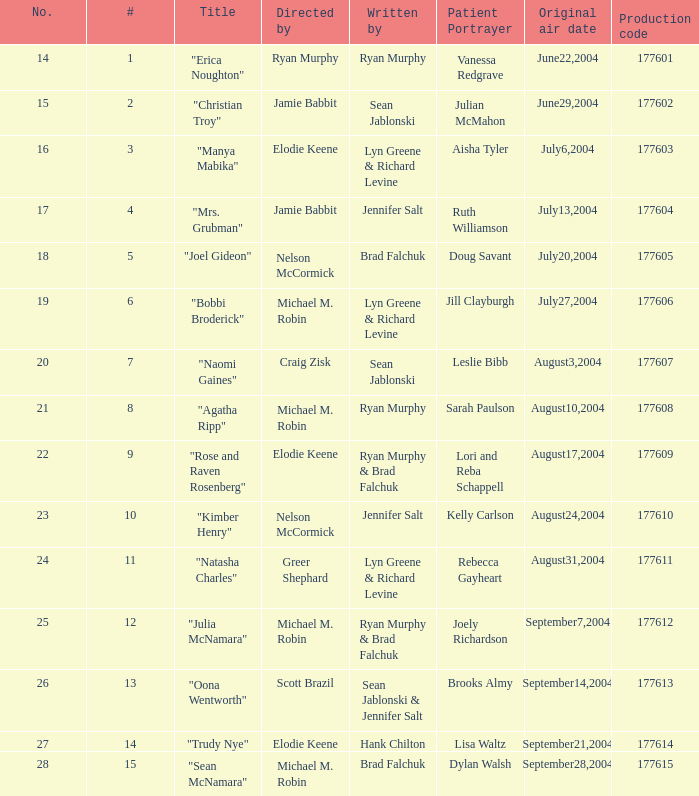Could you parse the entire table as a dict? {'header': ['No.', '#', 'Title', 'Directed by', 'Written by', 'Patient Portrayer', 'Original air date', 'Production code'], 'rows': [['14', '1', '"Erica Noughton"', 'Ryan Murphy', 'Ryan Murphy', 'Vanessa Redgrave', 'June22,2004', '177601'], ['15', '2', '"Christian Troy"', 'Jamie Babbit', 'Sean Jablonski', 'Julian McMahon', 'June29,2004', '177602'], ['16', '3', '"Manya Mabika"', 'Elodie Keene', 'Lyn Greene & Richard Levine', 'Aisha Tyler', 'July6,2004', '177603'], ['17', '4', '"Mrs. Grubman"', 'Jamie Babbit', 'Jennifer Salt', 'Ruth Williamson', 'July13,2004', '177604'], ['18', '5', '"Joel Gideon"', 'Nelson McCormick', 'Brad Falchuk', 'Doug Savant', 'July20,2004', '177605'], ['19', '6', '"Bobbi Broderick"', 'Michael M. Robin', 'Lyn Greene & Richard Levine', 'Jill Clayburgh', 'July27,2004', '177606'], ['20', '7', '"Naomi Gaines"', 'Craig Zisk', 'Sean Jablonski', 'Leslie Bibb', 'August3,2004', '177607'], ['21', '8', '"Agatha Ripp"', 'Michael M. Robin', 'Ryan Murphy', 'Sarah Paulson', 'August10,2004', '177608'], ['22', '9', '"Rose and Raven Rosenberg"', 'Elodie Keene', 'Ryan Murphy & Brad Falchuk', 'Lori and Reba Schappell', 'August17,2004', '177609'], ['23', '10', '"Kimber Henry"', 'Nelson McCormick', 'Jennifer Salt', 'Kelly Carlson', 'August24,2004', '177610'], ['24', '11', '"Natasha Charles"', 'Greer Shephard', 'Lyn Greene & Richard Levine', 'Rebecca Gayheart', 'August31,2004', '177611'], ['25', '12', '"Julia McNamara"', 'Michael M. Robin', 'Ryan Murphy & Brad Falchuk', 'Joely Richardson', 'September7,2004', '177612'], ['26', '13', '"Oona Wentworth"', 'Scott Brazil', 'Sean Jablonski & Jennifer Salt', 'Brooks Almy', 'September14,2004', '177613'], ['27', '14', '"Trudy Nye"', 'Elodie Keene', 'Hank Chilton', 'Lisa Waltz', 'September21,2004', '177614'], ['28', '15', '"Sean McNamara"', 'Michael M. Robin', 'Brad Falchuk', 'Dylan Walsh', 'September28,2004', '177615']]} Which episode, with the largest number, includes doug savant playing the role of a patient? 5.0. 